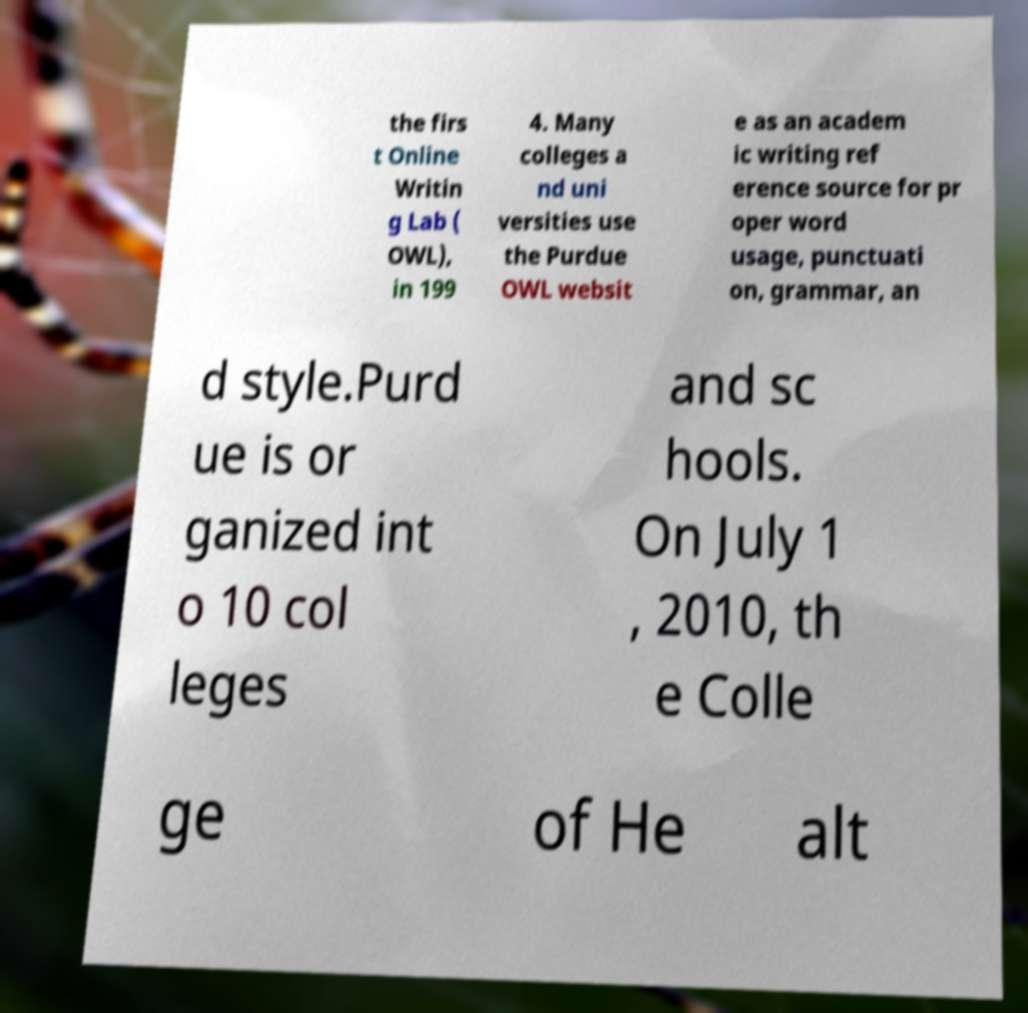There's text embedded in this image that I need extracted. Can you transcribe it verbatim? the firs t Online Writin g Lab ( OWL), in 199 4. Many colleges a nd uni versities use the Purdue OWL websit e as an academ ic writing ref erence source for pr oper word usage, punctuati on, grammar, an d style.Purd ue is or ganized int o 10 col leges and sc hools. On July 1 , 2010, th e Colle ge of He alt 